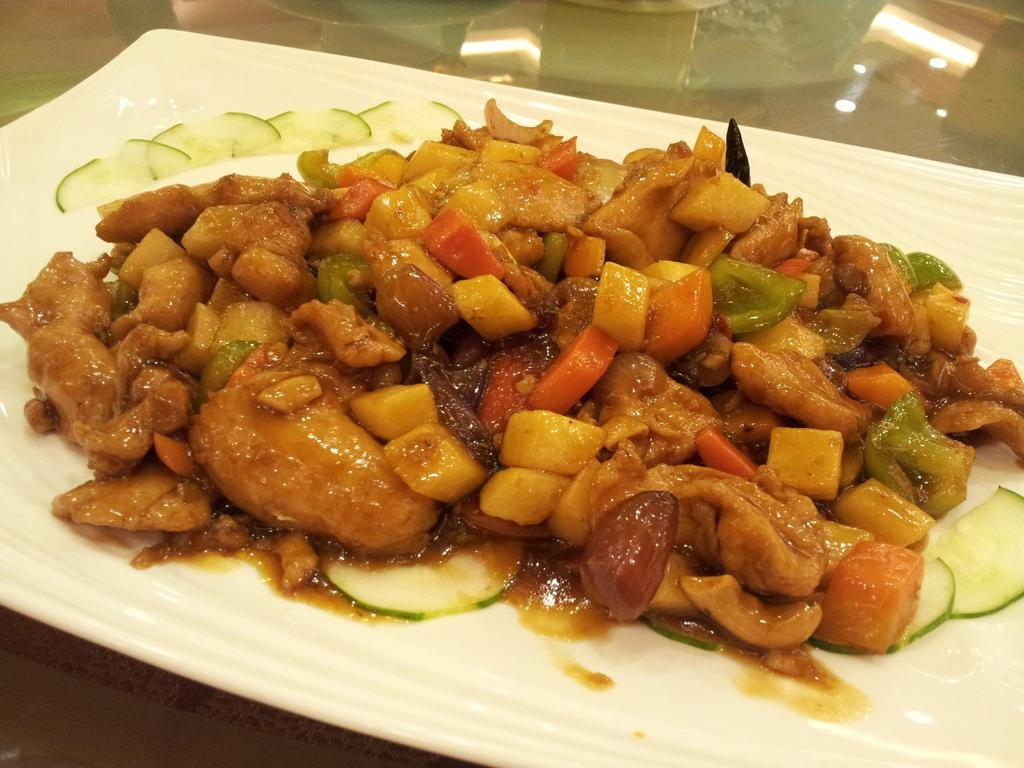What piece of furniture is present in the image? There is a table in the image. What is placed on the table? There is a plate containing food on the table. What direction is the table facing in the image? The direction the table is facing cannot be determined from the image. Is there a slope present in the image? There is no slope visible in the image. 